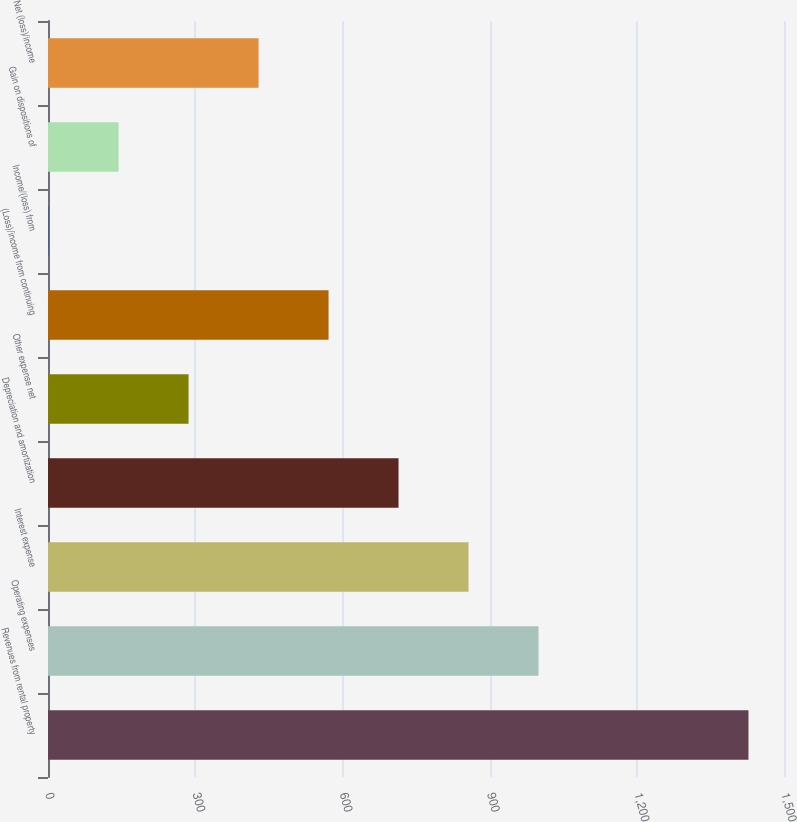Convert chart to OTSL. <chart><loc_0><loc_0><loc_500><loc_500><bar_chart><fcel>Revenues from rental property<fcel>Operating expenses<fcel>Interest expense<fcel>Depreciation and amortization<fcel>Other expense net<fcel>(Loss)/income from continuing<fcel>Income/(loss) from<fcel>Gain on dispositions of<fcel>Net (loss)/income<nl><fcel>1427.6<fcel>999.68<fcel>857.04<fcel>714.4<fcel>286.48<fcel>571.76<fcel>1.2<fcel>143.84<fcel>429.12<nl></chart> 